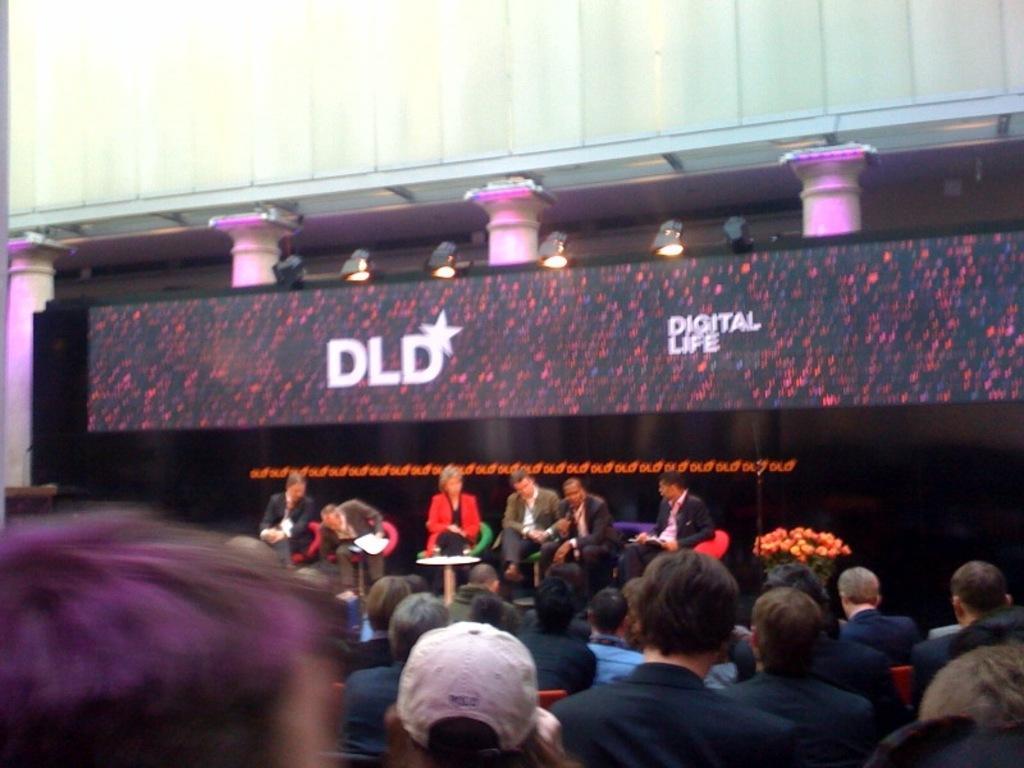Describe this image in one or two sentences. This image consists of many people. It looks like it is clicked outside. In the front, there are six persons sitting on the dais. There is a screen fixed to the pillars. At the top, there is a building. 